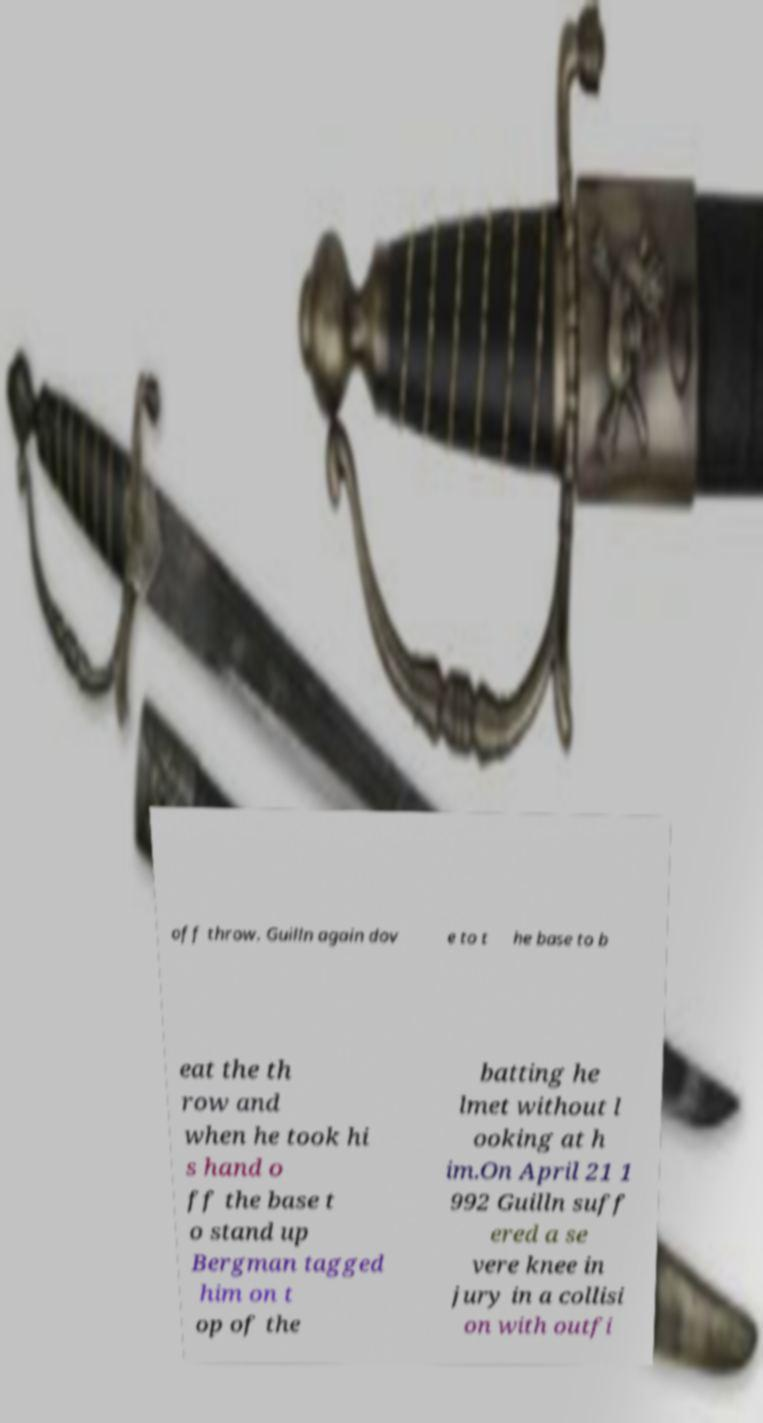Please read and relay the text visible in this image. What does it say? off throw. Guilln again dov e to t he base to b eat the th row and when he took hi s hand o ff the base t o stand up Bergman tagged him on t op of the batting he lmet without l ooking at h im.On April 21 1 992 Guilln suff ered a se vere knee in jury in a collisi on with outfi 